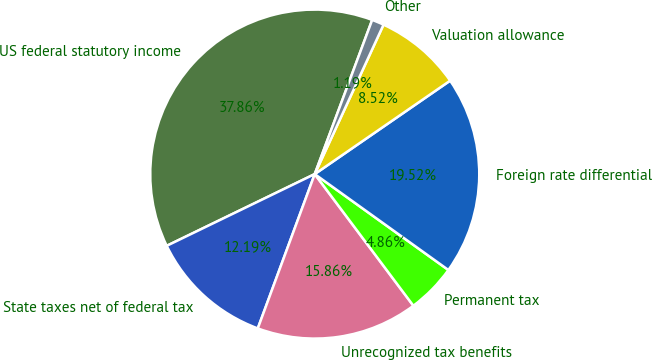Convert chart to OTSL. <chart><loc_0><loc_0><loc_500><loc_500><pie_chart><fcel>US federal statutory income<fcel>State taxes net of federal tax<fcel>Unrecognized tax benefits<fcel>Permanent tax<fcel>Foreign rate differential<fcel>Valuation allowance<fcel>Other<nl><fcel>37.86%<fcel>12.19%<fcel>15.86%<fcel>4.86%<fcel>19.52%<fcel>8.52%<fcel>1.19%<nl></chart> 